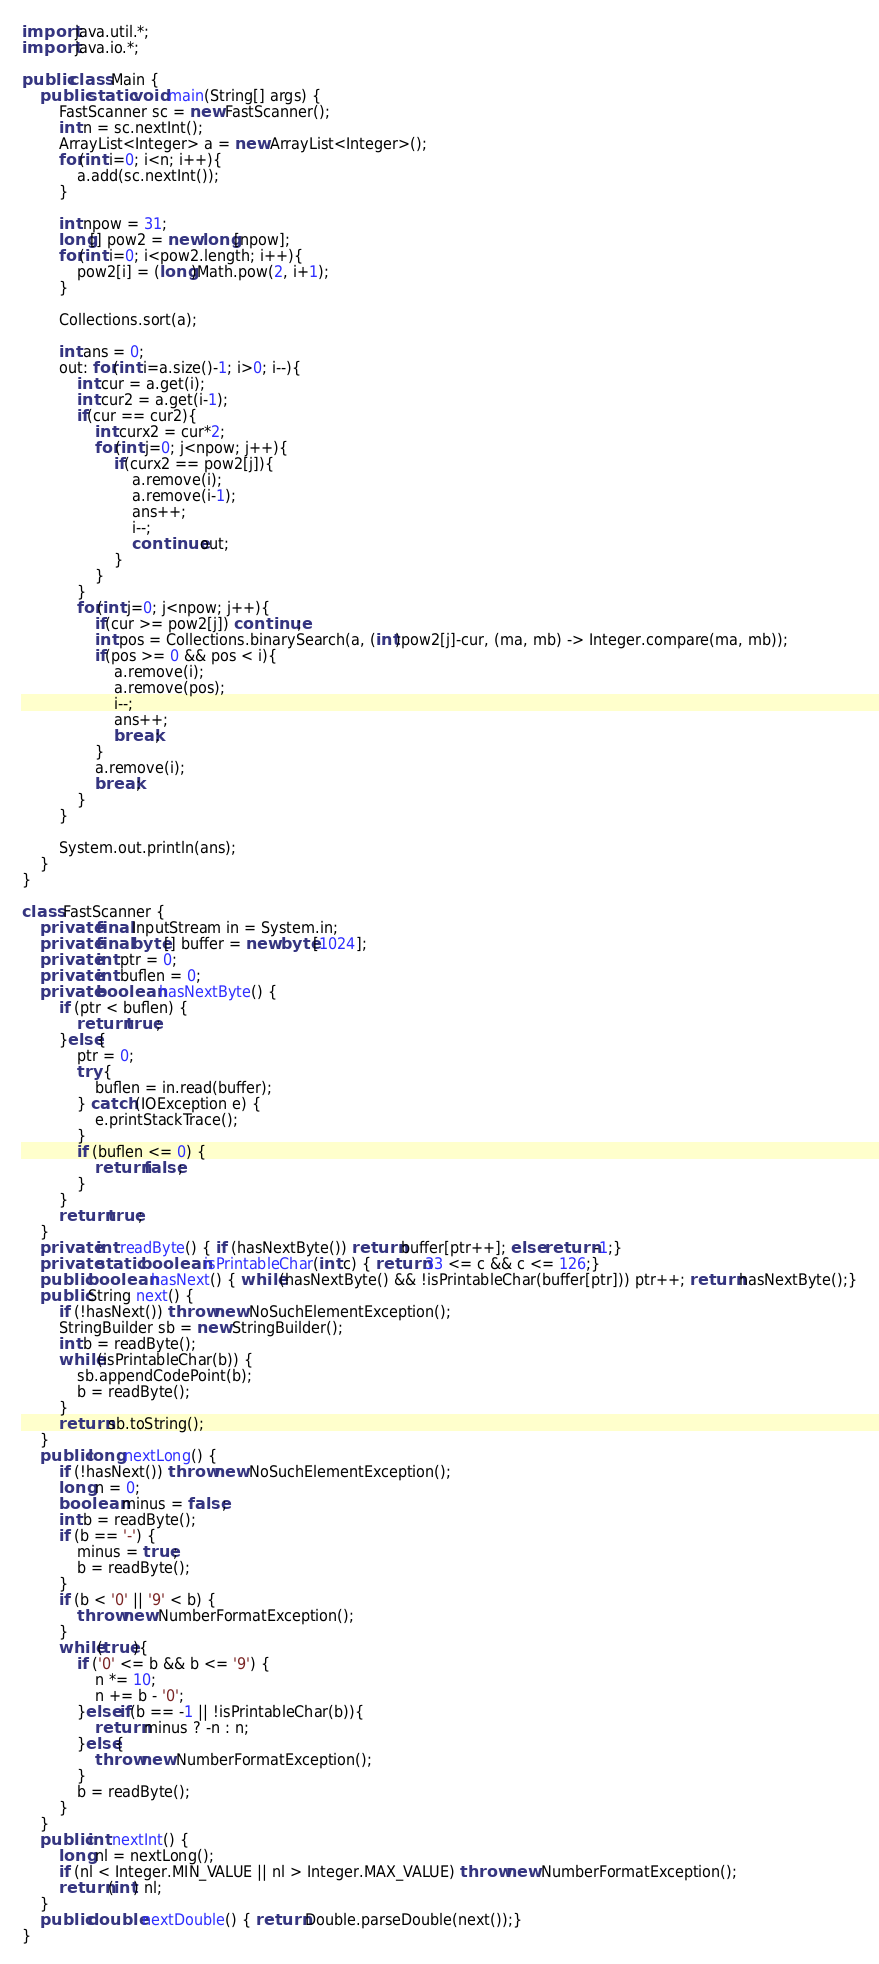Convert code to text. <code><loc_0><loc_0><loc_500><loc_500><_Java_>import java.util.*;
import java.io.*;

public class Main {
    public static void main(String[] args) {
        FastScanner sc = new FastScanner();
        int n = sc.nextInt();
        ArrayList<Integer> a = new ArrayList<Integer>();
        for(int i=0; i<n; i++){
            a.add(sc.nextInt());
        }

        int npow = 31;
        long[] pow2 = new long[npow];
        for(int i=0; i<pow2.length; i++){
            pow2[i] = (long)Math.pow(2, i+1);
        }

        Collections.sort(a);

        int ans = 0;
        out: for(int i=a.size()-1; i>0; i--){
            int cur = a.get(i);
            int cur2 = a.get(i-1);
            if(cur == cur2){
                int curx2 = cur*2;
                for(int j=0; j<npow; j++){
                    if(curx2 == pow2[j]){
                        a.remove(i);
                        a.remove(i-1);
                        ans++;
                        i--;
                        continue out;
                    }
                }
            }
            for(int j=0; j<npow; j++){
                if(cur >= pow2[j]) continue;
                int pos = Collections.binarySearch(a, (int)pow2[j]-cur, (ma, mb) -> Integer.compare(ma, mb));
                if(pos >= 0 && pos < i){
                    a.remove(i);
                    a.remove(pos);
                    i--;
                    ans++;
                    break;
                }
                a.remove(i);
                break;
            }
        }

        System.out.println(ans);
    }
}

class FastScanner {
    private final InputStream in = System.in;
    private final byte[] buffer = new byte[1024];
    private int ptr = 0;
    private int buflen = 0;
    private boolean hasNextByte() {
        if (ptr < buflen) {
            return true;
        }else{
            ptr = 0;
            try {
                buflen = in.read(buffer);
            } catch (IOException e) {
                e.printStackTrace();
            }
            if (buflen <= 0) {
                return false;
            }
        }
        return true;
    }
    private int readByte() { if (hasNextByte()) return buffer[ptr++]; else return -1;}
    private static boolean isPrintableChar(int c) { return 33 <= c && c <= 126;}
    public boolean hasNext() { while(hasNextByte() && !isPrintableChar(buffer[ptr])) ptr++; return hasNextByte();}
    public String next() {
        if (!hasNext()) throw new NoSuchElementException();
        StringBuilder sb = new StringBuilder();
        int b = readByte();
        while(isPrintableChar(b)) {
            sb.appendCodePoint(b);
            b = readByte();
        }
        return sb.toString();
    }
    public long nextLong() {
        if (!hasNext()) throw new NoSuchElementException();
        long n = 0;
        boolean minus = false;
        int b = readByte();
        if (b == '-') {
            minus = true;
            b = readByte();
        }
        if (b < '0' || '9' < b) {
            throw new NumberFormatException();
        }
        while(true){
            if ('0' <= b && b <= '9') {
                n *= 10;
                n += b - '0';
            }else if(b == -1 || !isPrintableChar(b)){
                return minus ? -n : n;
            }else{
                throw new NumberFormatException();
            }
            b = readByte();
        }
    }
    public int nextInt() {
        long nl = nextLong();
        if (nl < Integer.MIN_VALUE || nl > Integer.MAX_VALUE) throw new NumberFormatException();
        return (int) nl;
    }
    public double nextDouble() { return Double.parseDouble(next());}
}</code> 